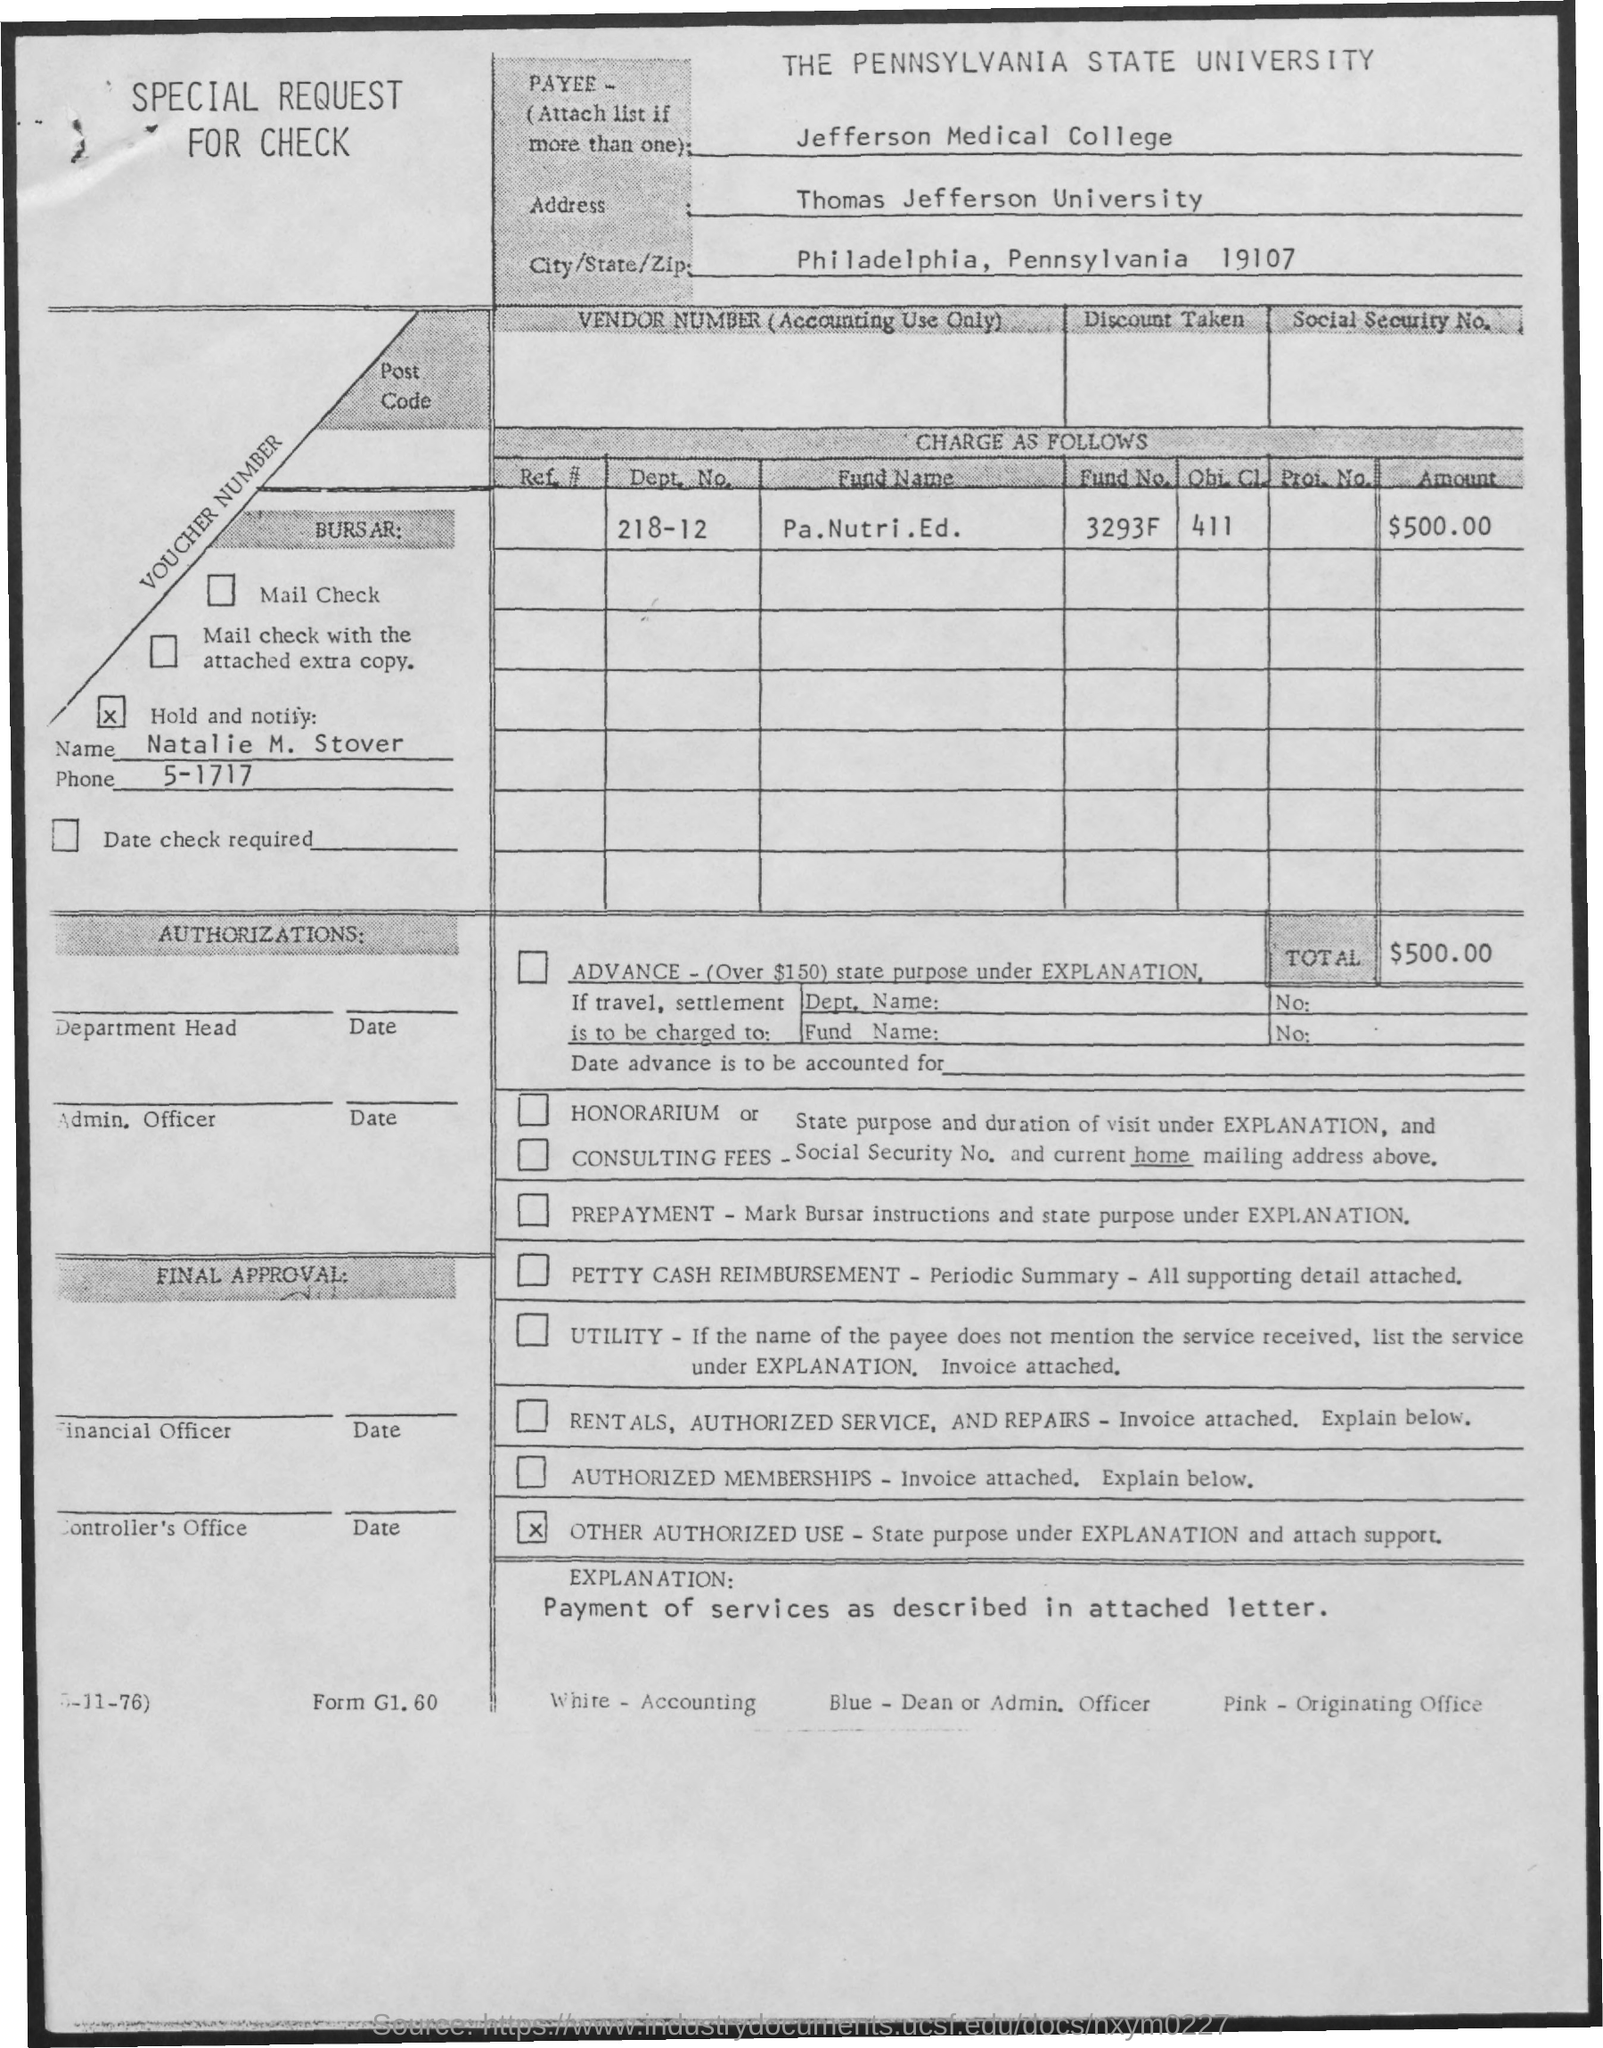Indicate a few pertinent items in this graphic. The phone number mentioned is 5-1717. The zip code mentioned is 19107. The name of the state mentioned is Pennsylvania. The given address mentions the name of Thomas Jefferson University. The department number mentioned is 218-12. 